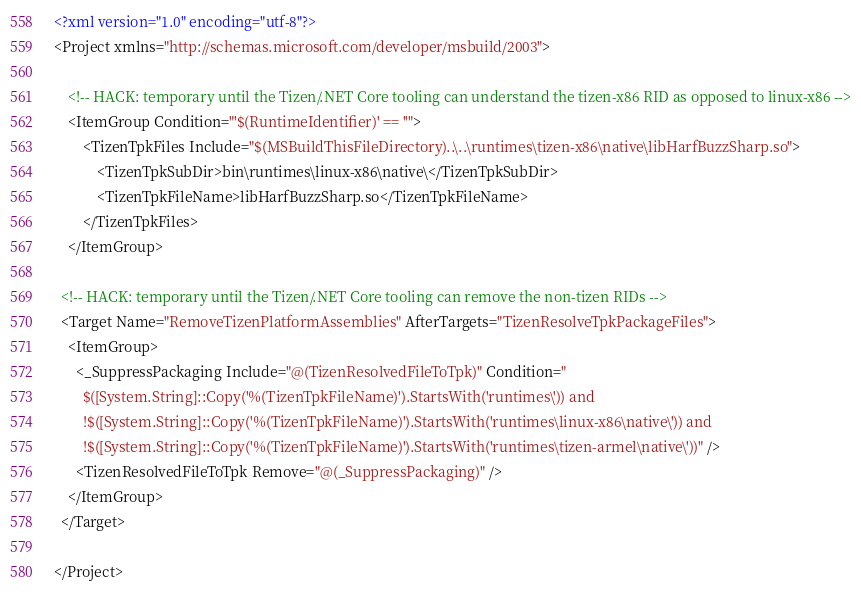<code> <loc_0><loc_0><loc_500><loc_500><_XML_><?xml version="1.0" encoding="utf-8"?>
<Project xmlns="http://schemas.microsoft.com/developer/msbuild/2003">

    <!-- HACK: temporary until the Tizen/.NET Core tooling can understand the tizen-x86 RID as opposed to linux-x86 -->
    <ItemGroup Condition="'$(RuntimeIdentifier)' == ''">
        <TizenTpkFiles Include="$(MSBuildThisFileDirectory)..\..\runtimes\tizen-x86\native\libHarfBuzzSharp.so">
            <TizenTpkSubDir>bin\runtimes\linux-x86\native\</TizenTpkSubDir>
            <TizenTpkFileName>libHarfBuzzSharp.so</TizenTpkFileName>
        </TizenTpkFiles>
    </ItemGroup>

  <!-- HACK: temporary until the Tizen/.NET Core tooling can remove the non-tizen RIDs -->
  <Target Name="RemoveTizenPlatformAssemblies" AfterTargets="TizenResolveTpkPackageFiles">
    <ItemGroup>
      <_SuppressPackaging Include="@(TizenResolvedFileToTpk)" Condition="
        $([System.String]::Copy('%(TizenTpkFileName)').StartsWith('runtimes\')) and
        !$([System.String]::Copy('%(TizenTpkFileName)').StartsWith('runtimes\linux-x86\native\')) and
        !$([System.String]::Copy('%(TizenTpkFileName)').StartsWith('runtimes\tizen-armel\native\'))" />
      <TizenResolvedFileToTpk Remove="@(_SuppressPackaging)" />
    </ItemGroup>
  </Target>

</Project></code> 